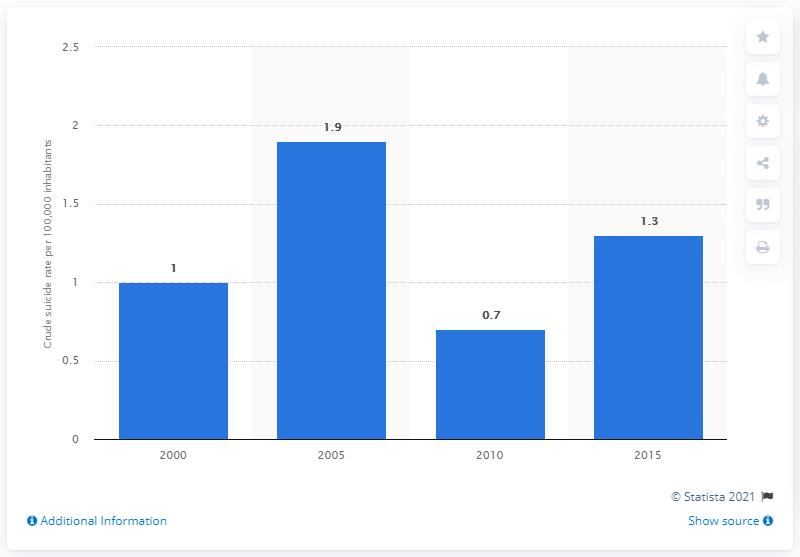Highlight a few significant elements in this photo. In 2015, the crude suicide rate in Brunei was 1.3 per 100,000 population. 